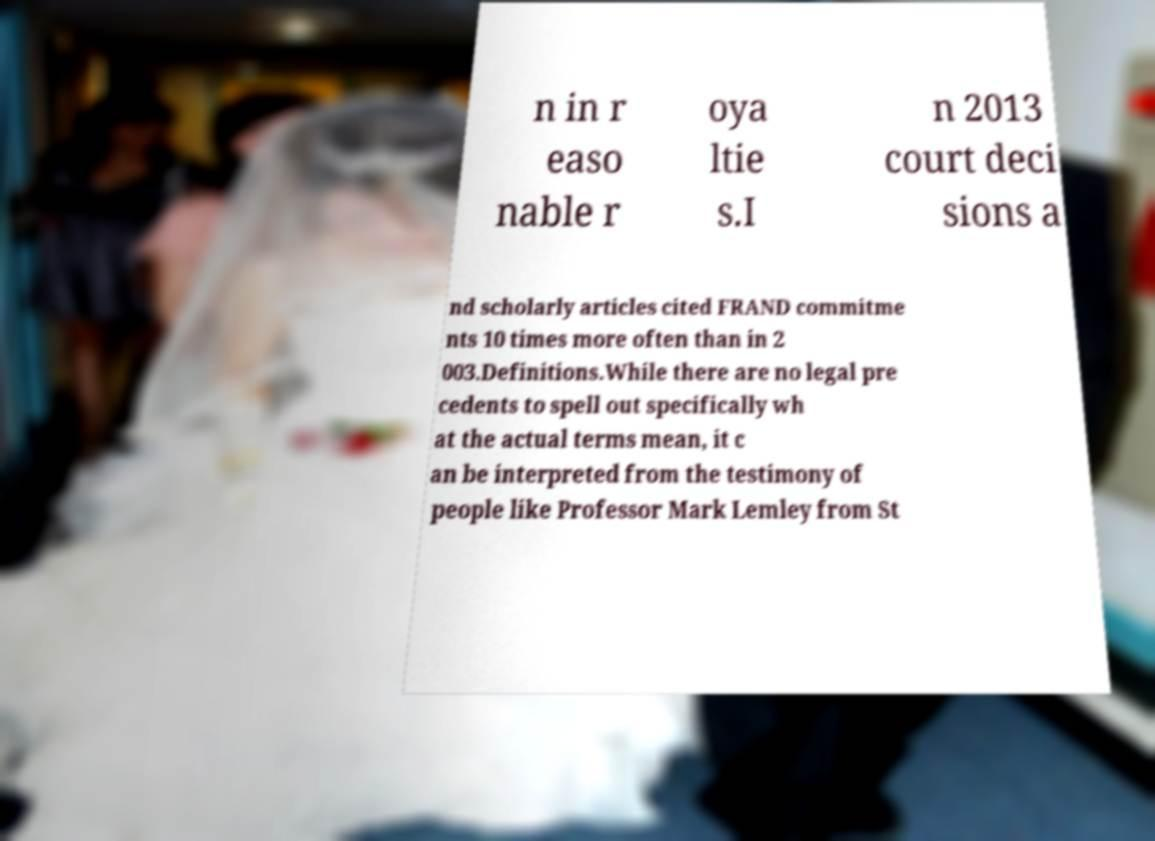Please read and relay the text visible in this image. What does it say? n in r easo nable r oya ltie s.I n 2013 court deci sions a nd scholarly articles cited FRAND commitme nts 10 times more often than in 2 003.Definitions.While there are no legal pre cedents to spell out specifically wh at the actual terms mean, it c an be interpreted from the testimony of people like Professor Mark Lemley from St 